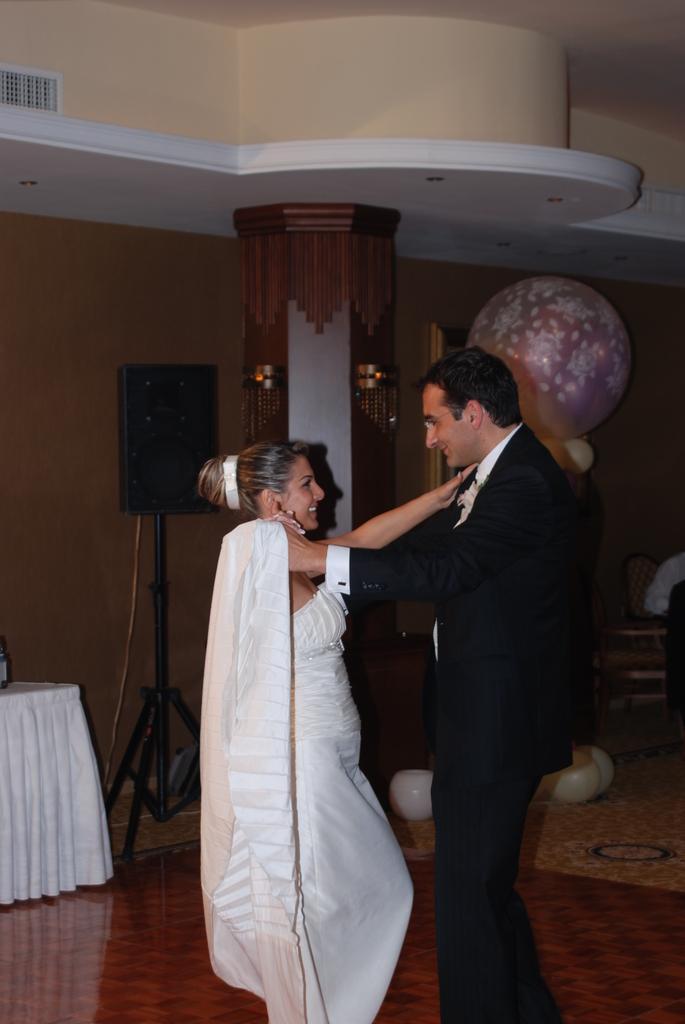Can you describe this image briefly? In this image in front there are two persons wearing a smile on their faces. At the bottom of the image there is a floor. On the left side of the image there is a table. On top of it there is some object. In the background of the image there are balloons. There is a wall and there are a few objects. 